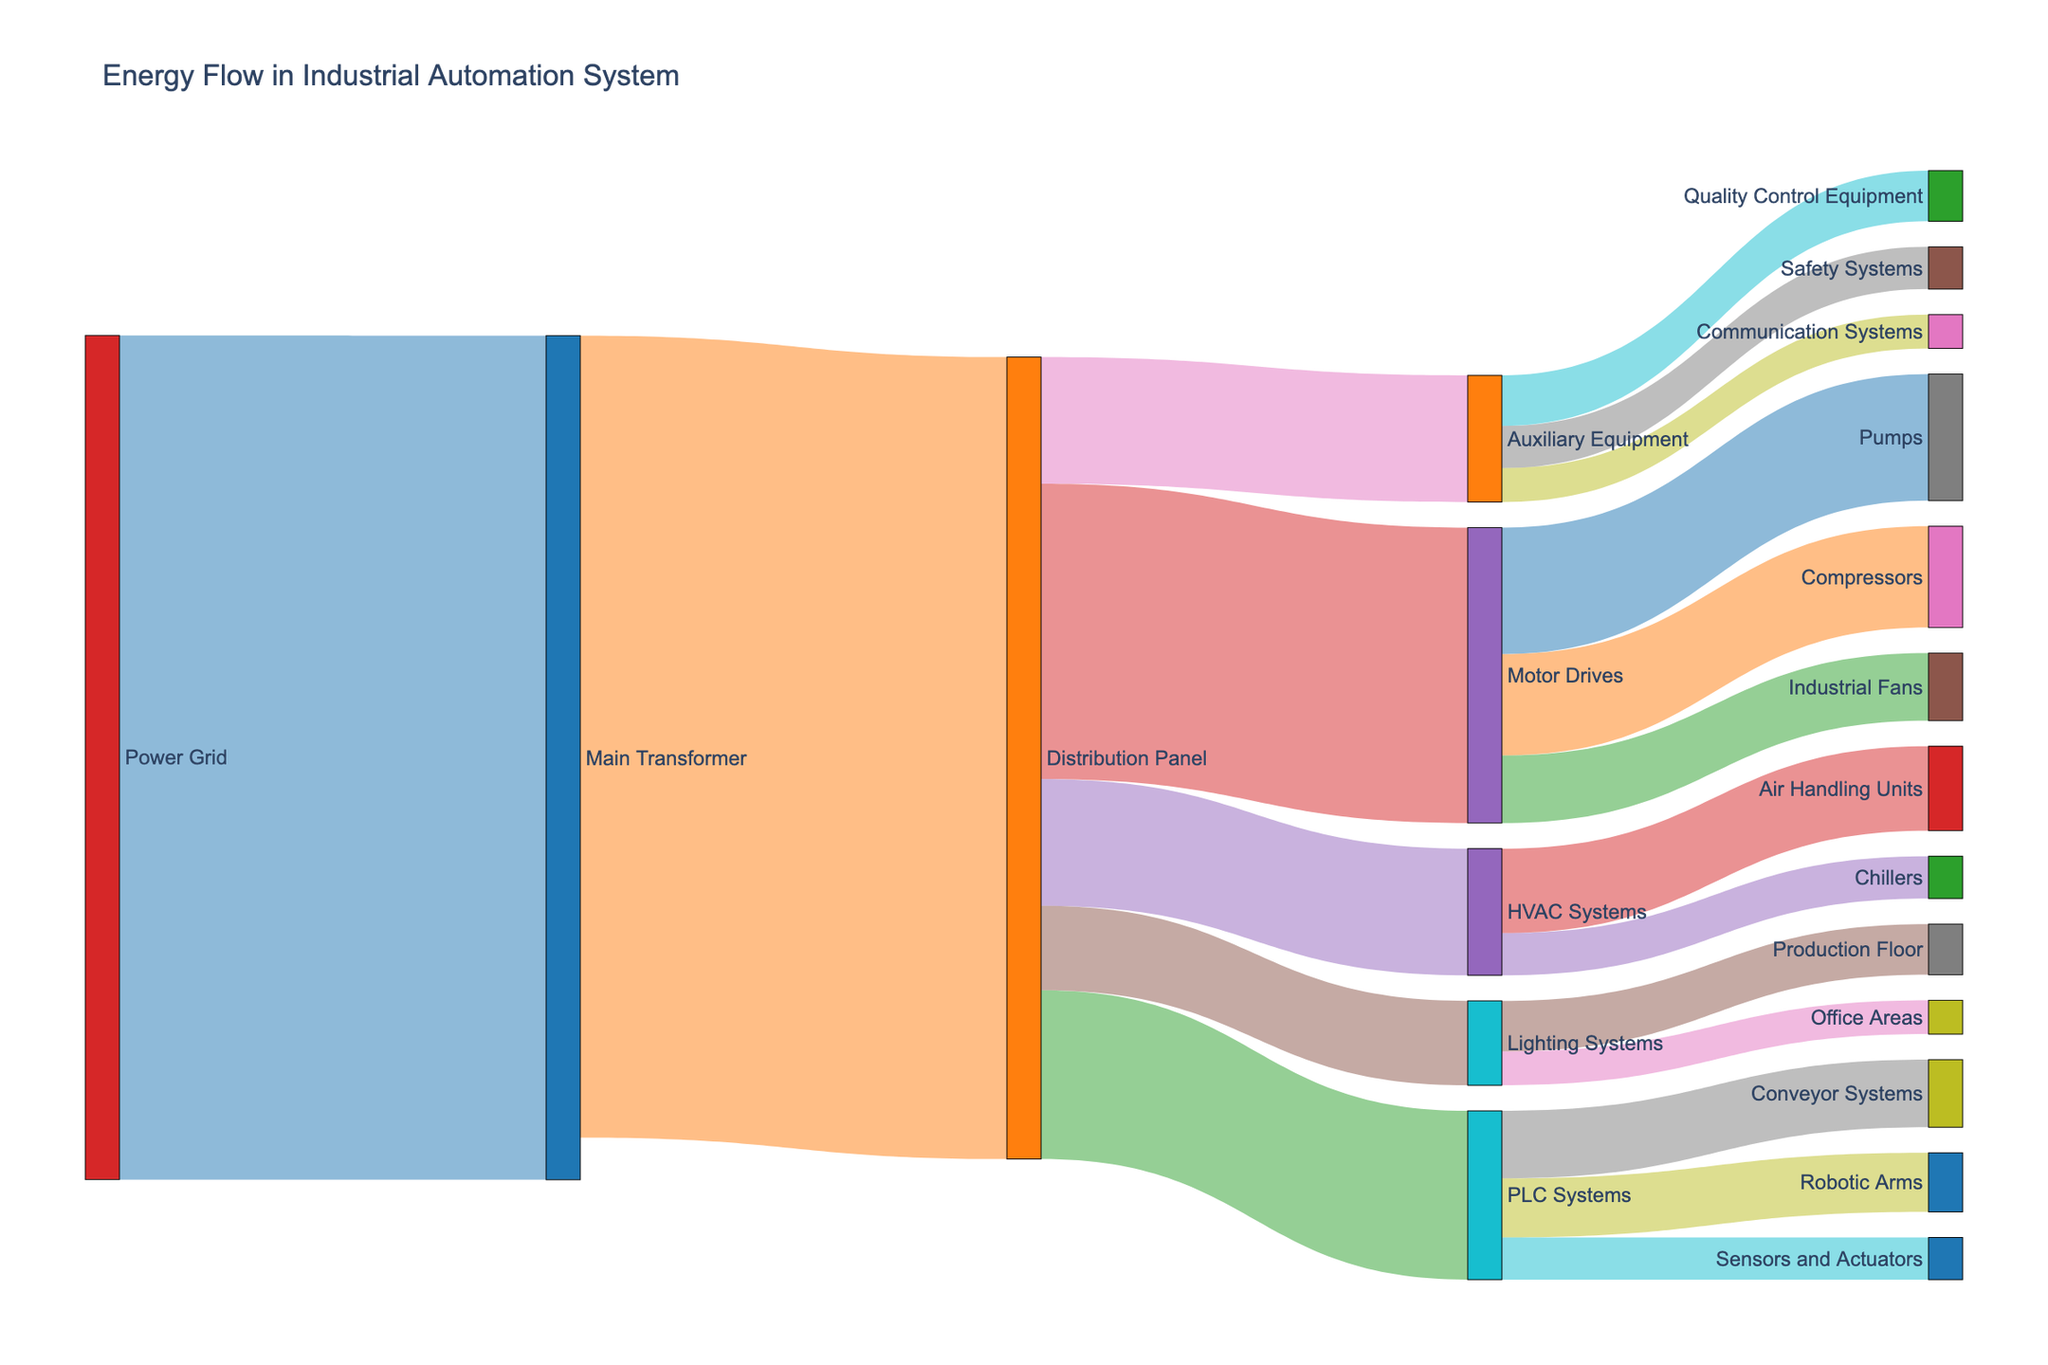what is the title of the figure? The title of the figure is displayed at the top of the diagram. It gives an overview of what the diagram represents.
Answer: "Energy Flow in Industrial Automation System" What are the main categories under the Distribution Panel? To determine the main categories, look for all the targets that are connected by links originating from the Distribution Panel.
Answer: PLC Systems, Motor Drives, HVAC Systems, Lighting Systems, Auxiliary Equipment What amount of energy flows from the Power Grid to the Main Transformer? Trace the link from the Power Grid to the Main Transformer and note the value labeled on this link, which represents the amount of energy flowing between these two nodes.
Answer: 1000 Which target under Motor Drives receives the highest energy? Compare the values associated with each target connected to Motor Drives to identify which one has the highest value.
Answer: Pumps What is the total energy flowing into the Distribution Panel? Sum the values of all the sources that feed into the Distribution Panel. Only one source, Main Transformer, with an energy value of 950 is directly connected to the Distribution Panel.
Answer: 950 How does the energy flowing to the Conveyor Systems compare to the energy flowing to the Robotic Arms under PLC Systems? Compare the values of the energy flowing to Conveyor Systems and Robotic Arms from PLC Systems.
Answer: Conveyor Systems receive 80, while Robotic Arms receive 70. Conveyor Systems have higher energy flow What is the sum of the energy used by the HVAC Systems? Sum up the energy values for both targets of HVAC Systems: Air Handling Units (100) and Chillers (50). 100 + 50 = 150
Answer: 150 In which part of the facility is the energy used for lighting? Check the targets under Lighting Systems to find out where the energy is directed, then identify the specific parts of the facility.
Answer: Production Floor and Office Areas What is the difference in energy flow between the Main Transformer and the total energy received by Distribution Panel? Subtract the total energy received by Distribution Panel (950) from the energy outflow from the Main Transformer (1000). 1000 - 950 = 50
Answer: 50 Which node in the distribution system has the most diverse connections (most targets)? Identify which node has the most links connecting to different targets, giving the most diverse connections.
Answer: Distribution Panel 